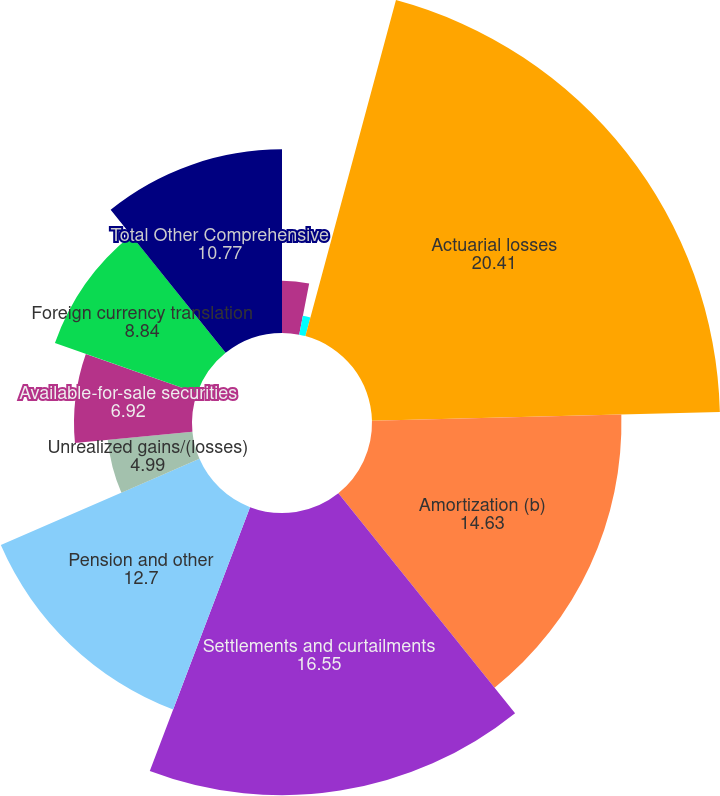Convert chart to OTSL. <chart><loc_0><loc_0><loc_500><loc_500><pie_chart><fcel>Reclassified to net earnings<fcel>Derivatives qualifying as cash<fcel>Actuarial losses<fcel>Amortization (b)<fcel>Settlements and curtailments<fcel>Pension and other<fcel>Unrealized gains/(losses)<fcel>Available-for-sale securities<fcel>Foreign currency translation<fcel>Total Other Comprehensive<nl><fcel>3.06%<fcel>1.13%<fcel>20.41%<fcel>14.63%<fcel>16.55%<fcel>12.7%<fcel>4.99%<fcel>6.92%<fcel>8.84%<fcel>10.77%<nl></chart> 